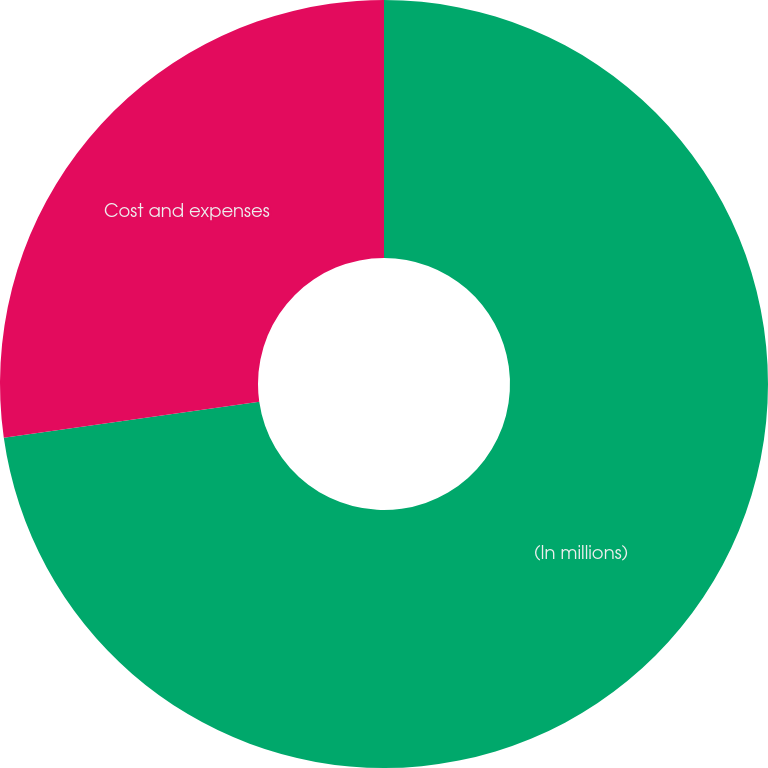<chart> <loc_0><loc_0><loc_500><loc_500><pie_chart><fcel>(In millions)<fcel>Cost and expenses<nl><fcel>72.76%<fcel>27.24%<nl></chart> 